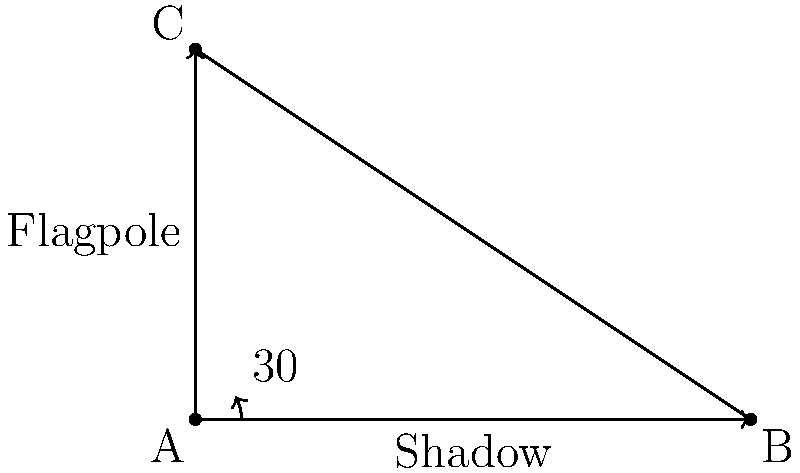As a behavior analyst, you're observing a geometry lesson where students are learning about trigonometry applications. The teacher presents a problem about finding the height of a flagpole using its shadow length and the angle of the sun. If the shadow of the flagpole is 6 meters long and the angle of elevation of the sun is 30°, what is the height of the flagpole? Round your answer to the nearest tenth of a meter. Let's approach this step-by-step:

1) In this problem, we have a right triangle where:
   - The shadow length is the adjacent side (6 meters)
   - The flagpole height is the opposite side (unknown)
   - The angle of elevation of the sun is 30°

2) We need to find the opposite side (flagpole height) using the adjacent side and the angle.

3) The trigonometric ratio that relates the opposite and adjacent sides with an angle is tangent:

   $\tan(\theta) = \frac{\text{opposite}}{\text{adjacent}}$

4) Let's call the flagpole height $h$. We can set up the equation:

   $\tan(30°) = \frac{h}{6}$

5) To solve for $h$, multiply both sides by 6:

   $6 \cdot \tan(30°) = h$

6) Now, let's calculate:
   - $\tan(30°) \approx 0.57735$
   - $6 \cdot 0.57735 \approx 3.4641$

7) Rounding to the nearest tenth:

   $h \approx 3.5$ meters

This problem demonstrates how trigonometry can be applied to real-world situations, which is an important aspect of reinforcing mathematical concepts in a classroom setting.
Answer: 3.5 meters 